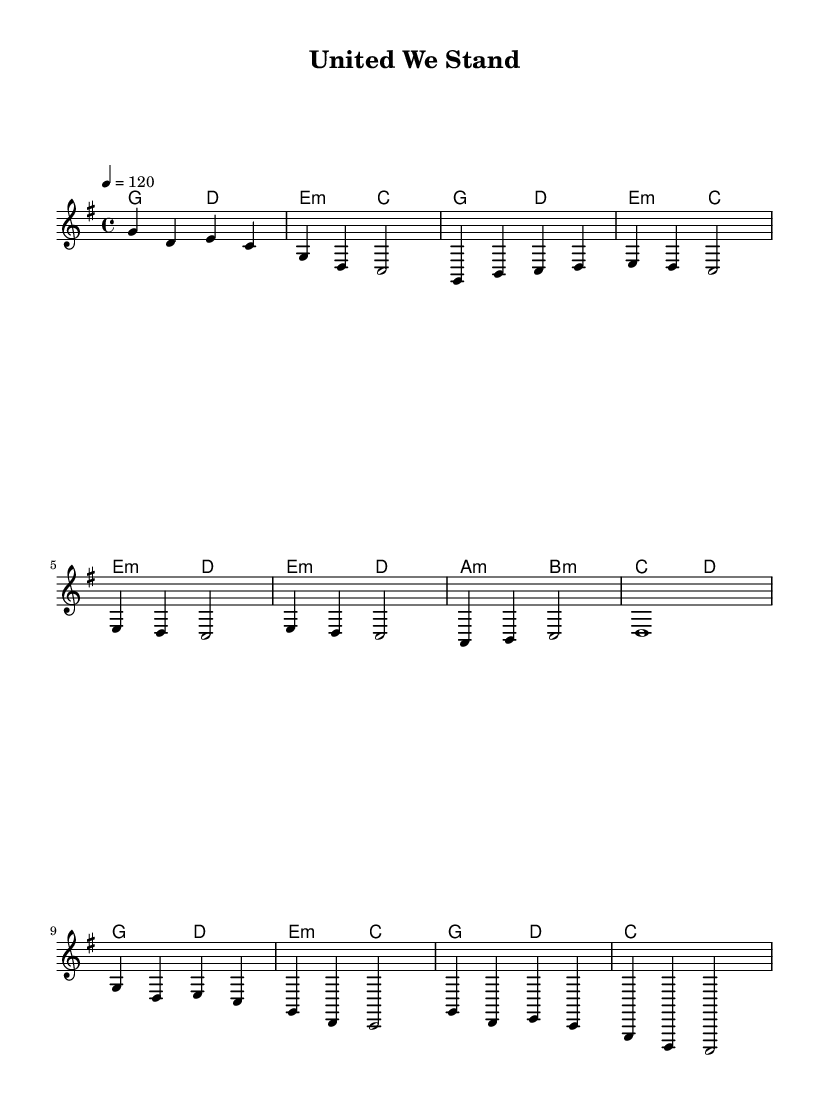What is the key signature of this music? The key signature is G major, which has one sharp (F#). This can be identified by looking at the raised note on the staff and knowing that G major is the scale that starts on G and has one sharp.
Answer: G major What is the time signature of this music? The time signature is 4/4, which means there are four beats per measure and the quarter note gets one beat. This is indicated at the beginning of the score where the time signature is shown as a '4' over another '4'.
Answer: 4/4 What is the tempo marking? The tempo marking is 120 beats per minute, indicated by the tempo text stating "4 = 120". This means the quarter note is played at 120 beats per minute, establishing a lively pace suitable for upbeat K-Pop.
Answer: 120 How many measures are in the chorus? The chorus consists of four measures, as seen in the section labeled "Chorus" in the sheet music. Each measure can be counted individually, leading to a total of four for that section.
Answer: 4 Which chord follows the E minor chord in the pre-chorus? The chord that follows the E minor chord in the pre-chorus is D. This can be determined by tracing the chord progression in the pre-chorus section, seeing the sequence of chords.
Answer: D What style of lyrics would suit this melody? Upbeat, positive, and community-oriented lyrics would suit this melody, as K-Pop often incorporates themes of resilience and togetherness. The uplifting nature of the melody implies an encouraging message that unites listeners.
Answer: Positive lyrics 